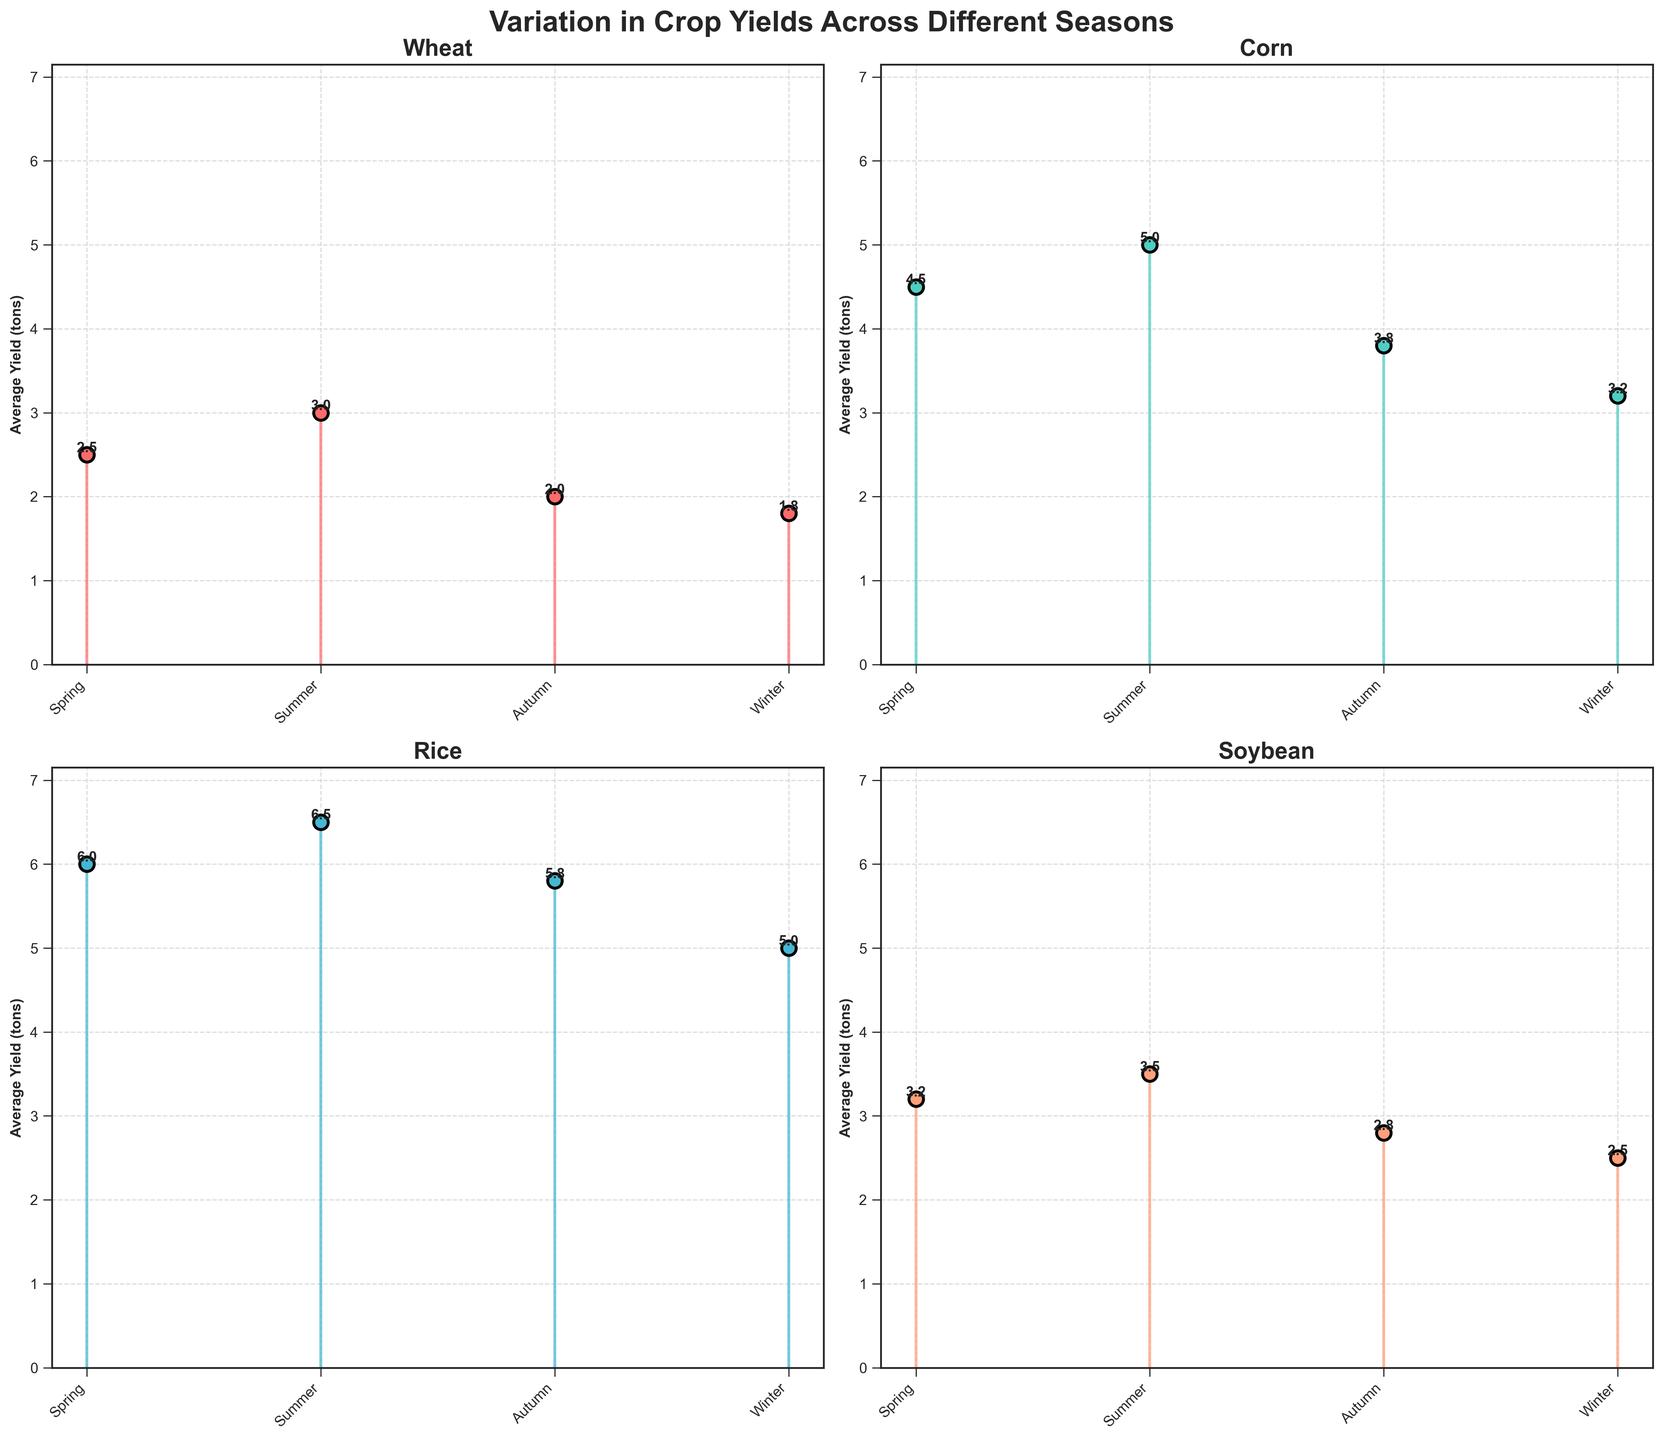What is the title of the figure? The title is usually placed at the top of the figure and is written in a bold font style. According to the code, the title of the figure is "Variation in Crop Yields Across Different Seasons".
Answer: Variation in Crop Yields Across Different Seasons How many subplots are present in the figure? The figure has a 2 by 2 layout of subplots, which means it has a total of 4 subplots. This is explicitly defined in the code via `fig, axs = plt.subplots(2, 2)`.
Answer: 4 Which crop has the highest yield in the summer season? In the subplot for each crop type, check the stem plot marker for the summer season. Corn has a yield of 5.0 tons in the summer, which is the highest among all crops.
Answer: Corn What is the average yield of Soybean across all seasons? Add up the yields for Soybean in all seasons: 3.2 (Spring) + 3.5 (Summer) + 2.8 (Autumn) + 2.5 (Winter) and divide by the number of seasons (4). (3.2 + 3.5 + 2.8 + 2.5) / 4 = 3
Answer: 3 In which season does Wheat have the lowest yield? Look at the subplot for Wheat and compare the yield values for each season. The lowest yield for Wheat is 1.8 tons in the Winter.
Answer: Winter Which season has the highest yield for Rice? In the subplot for Rice, the tallest stem represents the season with the highest yield. Rice has its highest yield of 6.5 tons in the Summer.
Answer: Summer How much more yield does Corn have in the Summer compared to Winter? Subtract the yield in Winter from the yield in Summer for Corn: 5.0 (Summer) - 3.2 (Winter) = 1.8
Answer: 1.8 Which crop has the most consistent yield across all seasons? Assess the subplots and identify the crop whose yields are most uniform across the seasons. Wheat shows the most consistency with its yields ranging close to 2.5, 3.0, 2.0, and 1.8.
Answer: Wheat Which season shows the greatest variation in average yield across all crops? Calculate the range (difference between maximum and minimum yields) for each season across all crops and compare. Winter shows the greatest variation with yields ranging from 5.0 for Rice to 1.8 for Wheat, a difference of 3.2.
Answer: Winter 